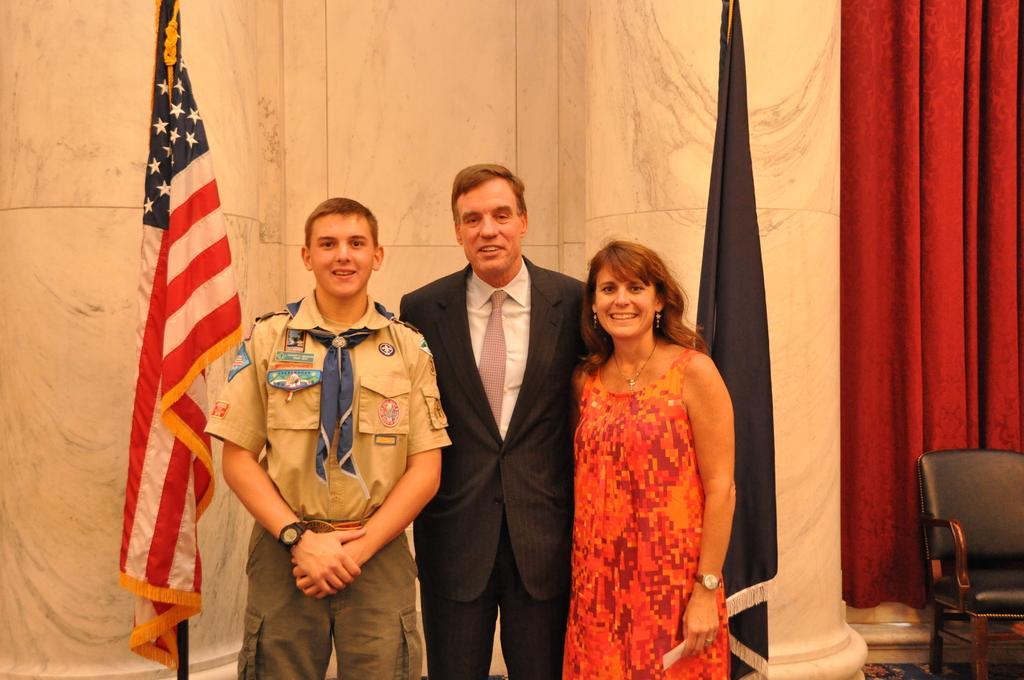In one or two sentences, can you explain what this image depicts? Three people are standing and laughing. In the middle one, he is wearing suit, shirt and tie. On left to him, there is a woman wearing orange color dress. On right to him, a boy. He is wearing a gray color shirt and watch. On right to them, there is a flag, on right to them, there is a flag. On the right side of the image, there is a red color curtain, chair and pillar. 